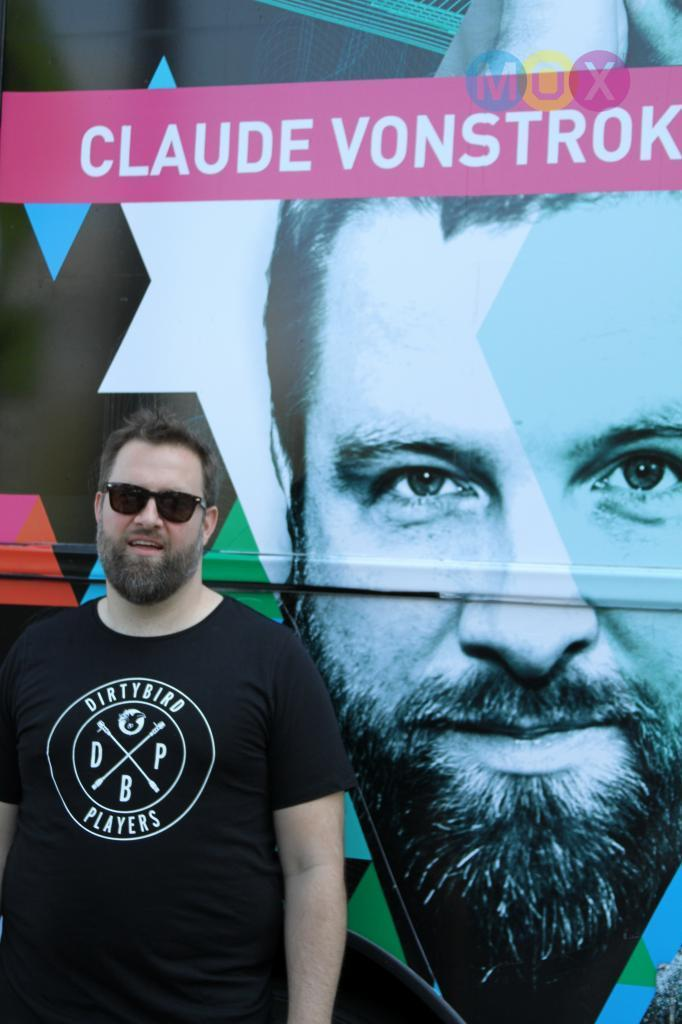What is the main subject of the image? There is a man standing in the image. What is the man wearing in the image? The man is wearing a black shirt. What can be seen in the background of the image? There is a poster in the background of the image. How many trucks are visible in the image? There are no trucks visible in the image; it only features a man standing and a poster in the background. 